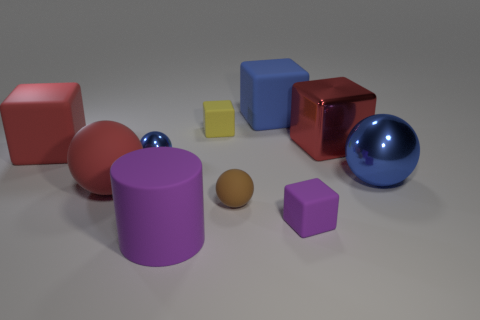Subtract all brown balls. How many balls are left? 3 Subtract 3 cubes. How many cubes are left? 2 Subtract all purple cubes. How many cubes are left? 4 Subtract all yellow spheres. Subtract all brown cylinders. How many spheres are left? 4 Subtract all balls. How many objects are left? 6 Add 9 purple cylinders. How many purple cylinders exist? 10 Subtract 1 blue spheres. How many objects are left? 9 Subtract all big gray cylinders. Subtract all big objects. How many objects are left? 4 Add 3 large red matte blocks. How many large red matte blocks are left? 4 